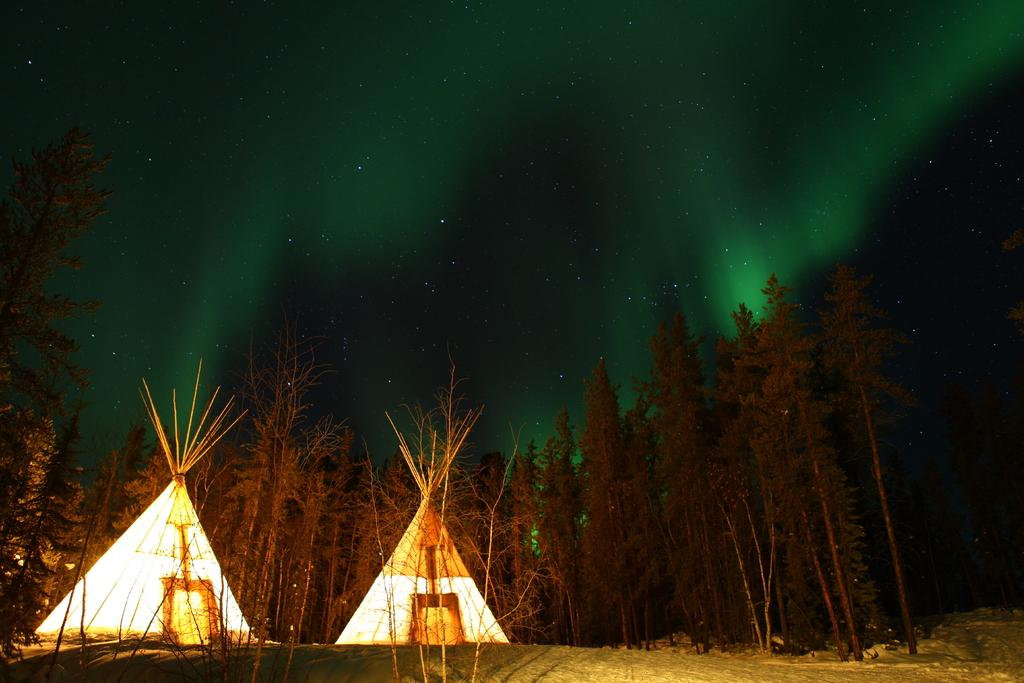How many tents are visible on the land in the image? There are two tents on the land in the image. What can be seen in the background of the image? There are trees in the background of the image. What is visible at the top of the image? The sky is visible at the top of the image. How many snakes are crawling on the picture in the image? There are no snakes or pictures present in the image; it features two tents and a background with trees. What is the thumb doing in the image? There is no thumb visible in the image. 